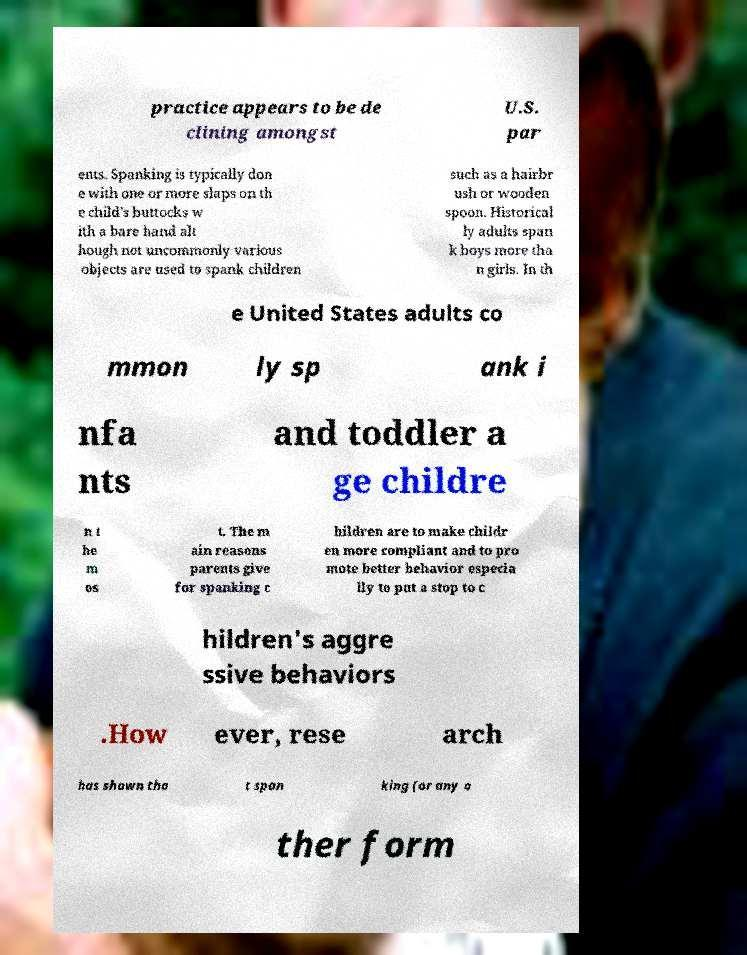What messages or text are displayed in this image? I need them in a readable, typed format. practice appears to be de clining amongst U.S. par ents. Spanking is typically don e with one or more slaps on th e child's buttocks w ith a bare hand alt hough not uncommonly various objects are used to spank children such as a hairbr ush or wooden spoon. Historical ly adults span k boys more tha n girls. In th e United States adults co mmon ly sp ank i nfa nts and toddler a ge childre n t he m os t. The m ain reasons parents give for spanking c hildren are to make childr en more compliant and to pro mote better behavior especia lly to put a stop to c hildren's aggre ssive behaviors .How ever, rese arch has shown tha t span king (or any o ther form 